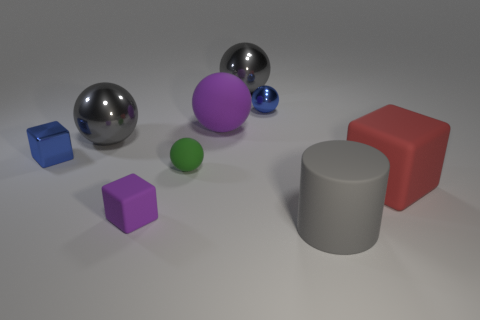Subtract all large balls. How many balls are left? 2 Add 1 large gray metallic balls. How many objects exist? 10 Subtract all blue cubes. How many cubes are left? 2 Subtract all spheres. How many objects are left? 4 Subtract all rubber spheres. Subtract all purple matte blocks. How many objects are left? 6 Add 5 blocks. How many blocks are left? 8 Add 2 large brown rubber cubes. How many large brown rubber cubes exist? 2 Subtract 1 blue blocks. How many objects are left? 8 Subtract 1 cylinders. How many cylinders are left? 0 Subtract all cyan spheres. Subtract all yellow cubes. How many spheres are left? 5 